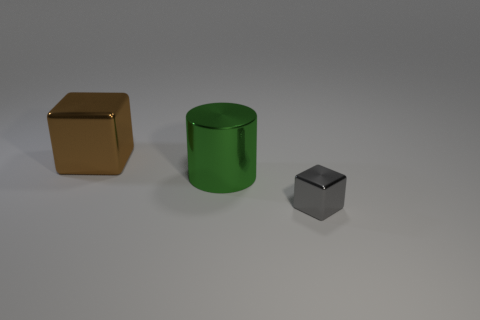There is a block behind the metallic cube that is to the right of the large object that is behind the shiny cylinder; what is its material?
Keep it short and to the point. Metal. Is the size of the green metallic thing the same as the brown metal cube?
Offer a terse response. Yes. What is the material of the big cylinder?
Provide a succinct answer. Metal. There is a big object that is left of the green object; is its shape the same as the tiny shiny object?
Your response must be concise. Yes. What number of things are large brown shiny blocks or tiny shiny blocks?
Make the answer very short. 2. Is the material of the thing that is on the left side of the green cylinder the same as the gray block?
Provide a short and direct response. Yes. The brown metallic thing is what size?
Provide a succinct answer. Large. What number of cylinders are either big green metal things or tiny shiny things?
Ensure brevity in your answer.  1. Are there an equal number of brown metal things that are on the right side of the tiny gray block and green things right of the big green metallic object?
Provide a short and direct response. Yes. There is another object that is the same shape as the large brown thing; what size is it?
Keep it short and to the point. Small. 